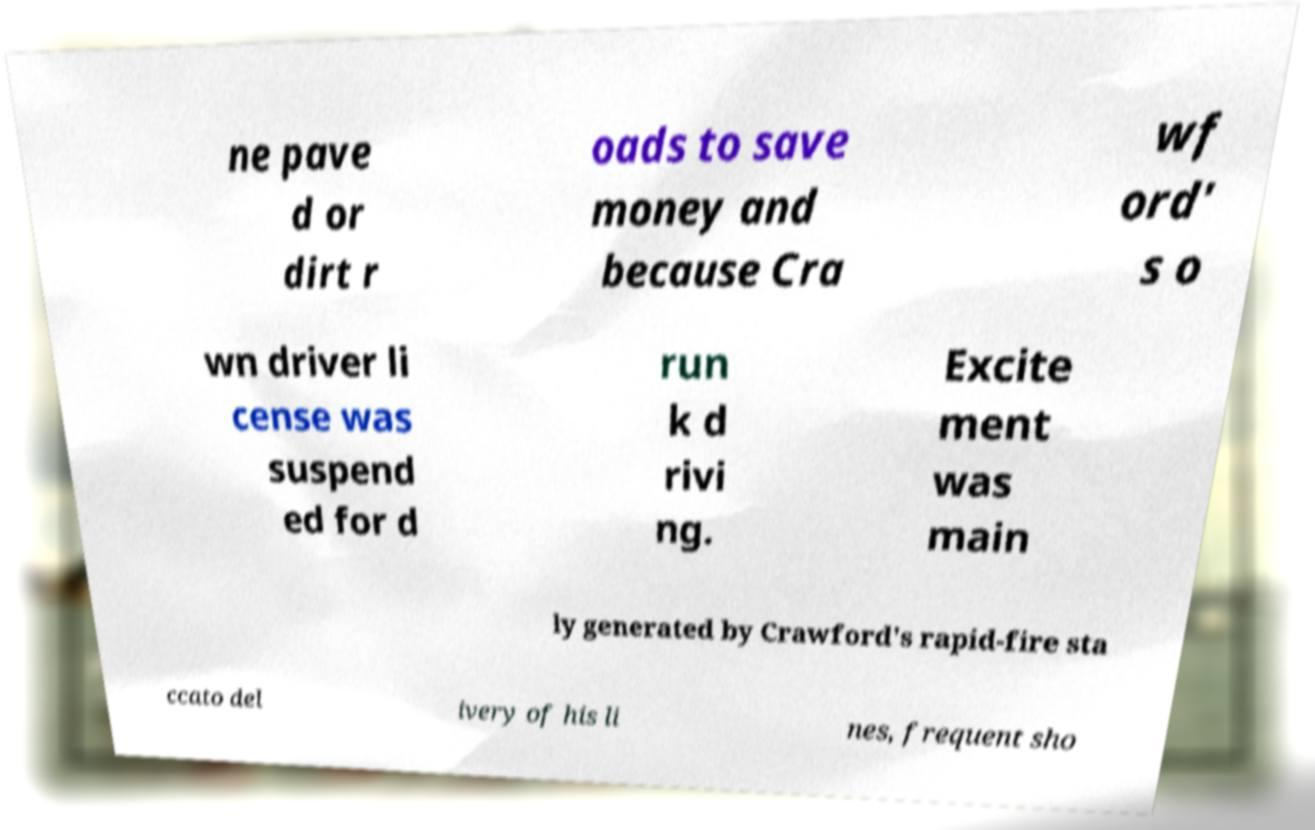Can you read and provide the text displayed in the image?This photo seems to have some interesting text. Can you extract and type it out for me? ne pave d or dirt r oads to save money and because Cra wf ord' s o wn driver li cense was suspend ed for d run k d rivi ng. Excite ment was main ly generated by Crawford's rapid-fire sta ccato del ivery of his li nes, frequent sho 